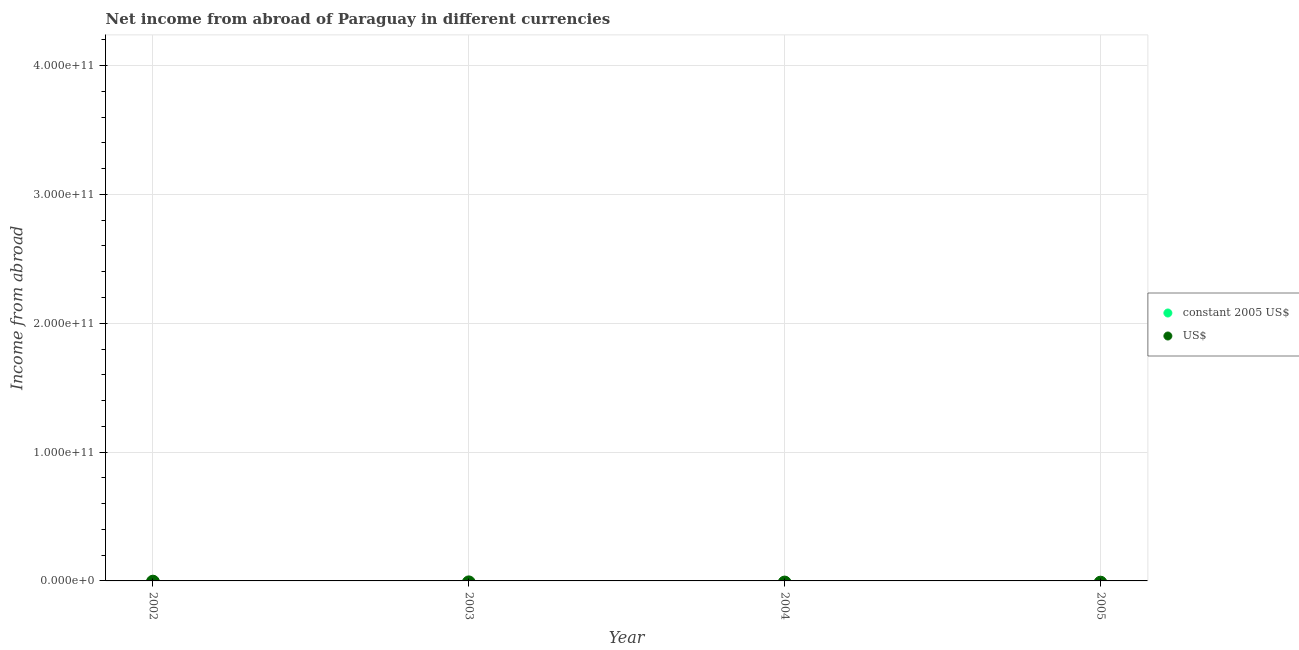Across all years, what is the minimum income from abroad in constant 2005 us$?
Offer a terse response. 0. What is the total income from abroad in us$ in the graph?
Keep it short and to the point. 0. What is the difference between the income from abroad in us$ in 2002 and the income from abroad in constant 2005 us$ in 2005?
Provide a short and direct response. 0. What is the average income from abroad in constant 2005 us$ per year?
Offer a very short reply. 0. How many dotlines are there?
Provide a short and direct response. 0. How many years are there in the graph?
Make the answer very short. 4. What is the difference between two consecutive major ticks on the Y-axis?
Your answer should be compact. 1.00e+11. Does the graph contain any zero values?
Offer a very short reply. Yes. Where does the legend appear in the graph?
Provide a succinct answer. Center right. How are the legend labels stacked?
Your answer should be compact. Vertical. What is the title of the graph?
Your answer should be compact. Net income from abroad of Paraguay in different currencies. What is the label or title of the Y-axis?
Give a very brief answer. Income from abroad. What is the Income from abroad in US$ in 2002?
Provide a short and direct response. 0. What is the Income from abroad in constant 2005 US$ in 2003?
Give a very brief answer. 0. What is the Income from abroad in constant 2005 US$ in 2004?
Provide a succinct answer. 0. What is the Income from abroad of US$ in 2004?
Keep it short and to the point. 0. What is the Income from abroad of constant 2005 US$ in 2005?
Your response must be concise. 0. What is the Income from abroad in US$ in 2005?
Your answer should be compact. 0. What is the average Income from abroad of constant 2005 US$ per year?
Make the answer very short. 0. 